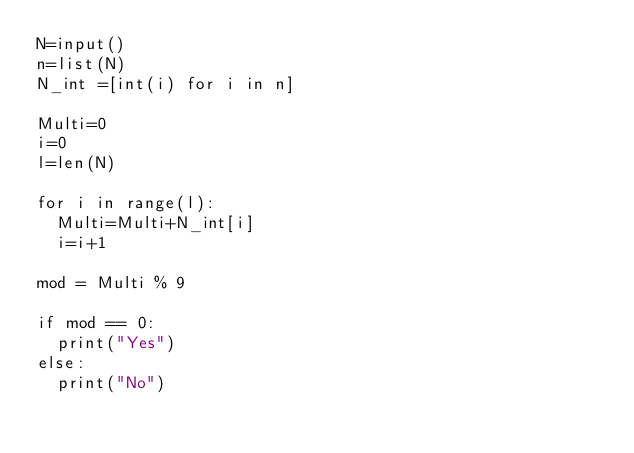Convert code to text. <code><loc_0><loc_0><loc_500><loc_500><_Python_>N=input()
n=list(N)
N_int =[int(i) for i in n]

Multi=0
i=0
l=len(N)

for i in range(l):
	Multi=Multi+N_int[i]
	i=i+1

mod = Multi % 9

if mod == 0:
  print("Yes")
else:
  print("No")</code> 